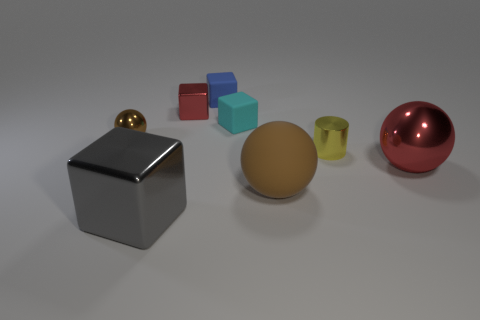Subtract all small spheres. How many spheres are left? 2 Subtract all cyan cubes. How many cubes are left? 3 Add 1 big things. How many objects exist? 9 Subtract all brown blocks. Subtract all cyan cylinders. How many blocks are left? 4 Subtract all brown blocks. How many cyan cylinders are left? 0 Subtract all small matte balls. Subtract all big metallic balls. How many objects are left? 7 Add 2 brown metal spheres. How many brown metal spheres are left? 3 Add 3 cyan matte blocks. How many cyan matte blocks exist? 4 Subtract 0 cyan cylinders. How many objects are left? 8 Subtract all cylinders. How many objects are left? 7 